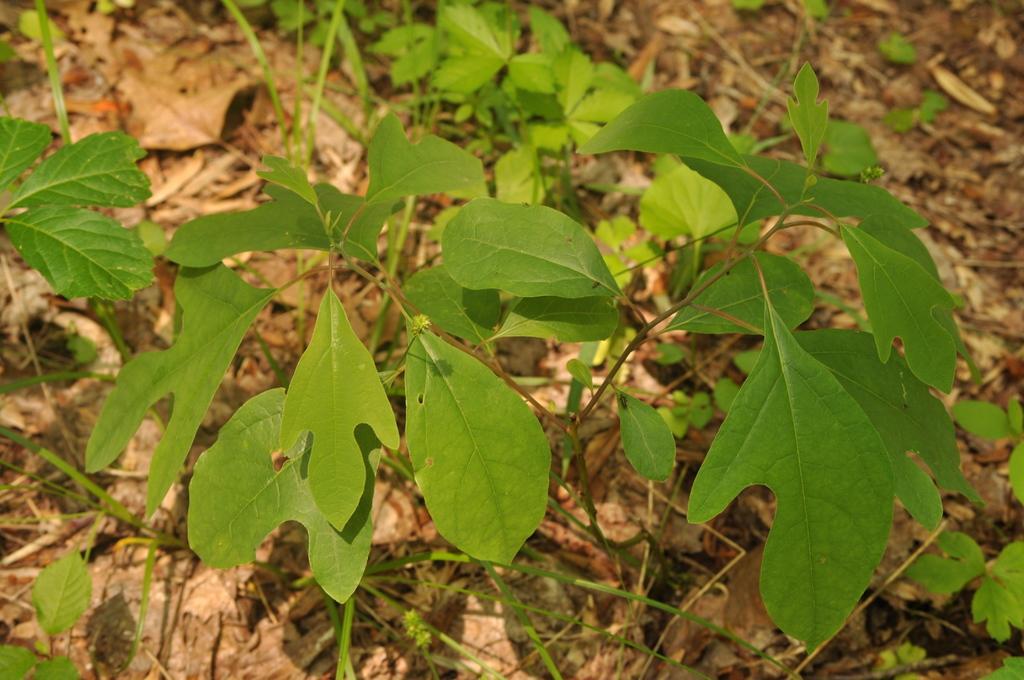Could you give a brief overview of what you see in this image? In this picture we can see plants and dried leaves on the ground. 